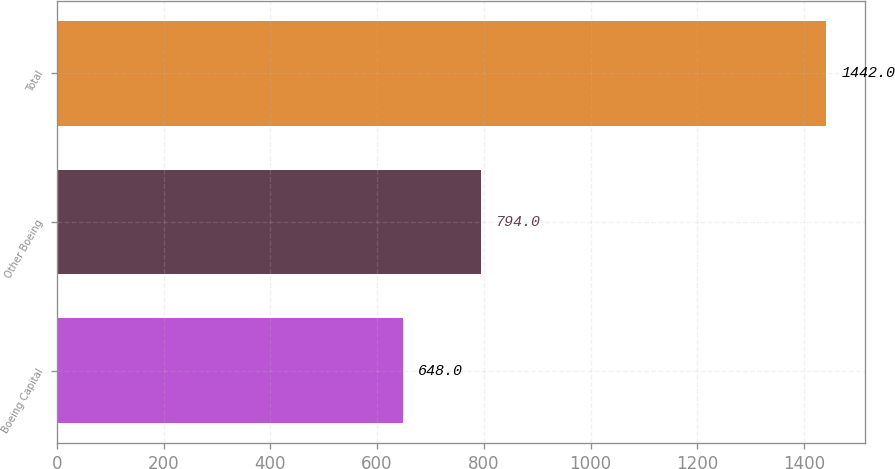Convert chart. <chart><loc_0><loc_0><loc_500><loc_500><bar_chart><fcel>Boeing Capital<fcel>Other Boeing<fcel>Total<nl><fcel>648<fcel>794<fcel>1442<nl></chart> 